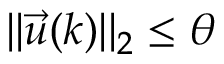Convert formula to latex. <formula><loc_0><loc_0><loc_500><loc_500>| | \vec { u } ( k ) | | _ { 2 } \leq \theta</formula> 